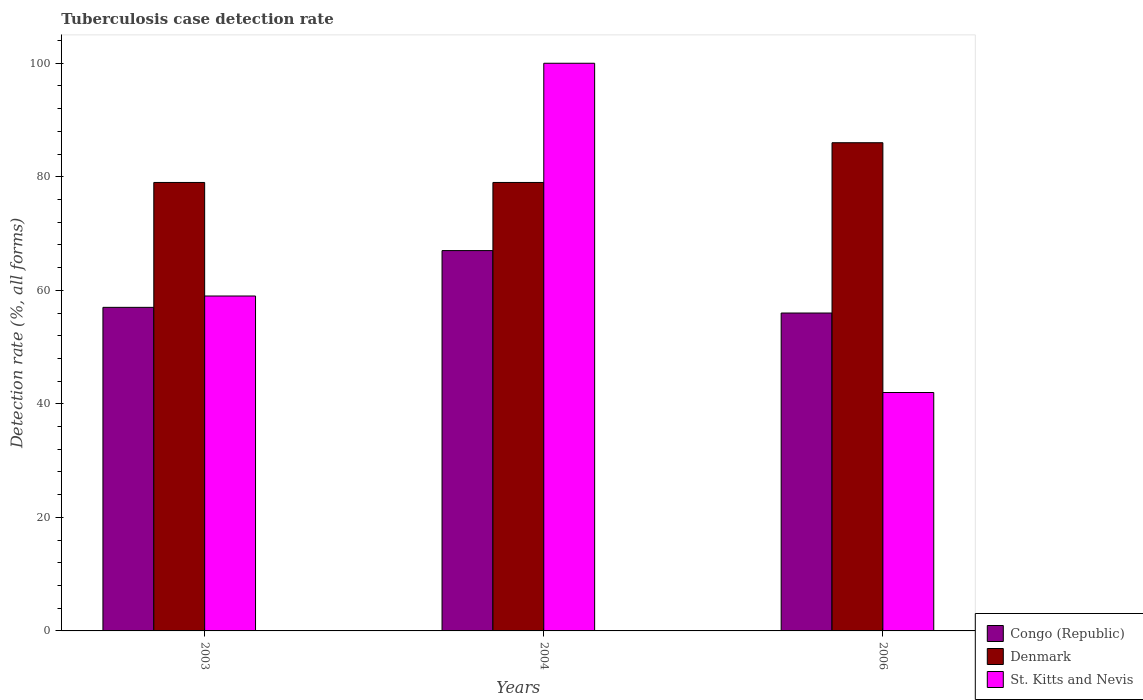Are the number of bars per tick equal to the number of legend labels?
Offer a very short reply. Yes. How many bars are there on the 1st tick from the left?
Your response must be concise. 3. What is the label of the 3rd group of bars from the left?
Offer a very short reply. 2006. In how many cases, is the number of bars for a given year not equal to the number of legend labels?
Your answer should be very brief. 0. What is the tuberculosis case detection rate in in Congo (Republic) in 2006?
Your answer should be compact. 56. Across all years, what is the maximum tuberculosis case detection rate in in Congo (Republic)?
Give a very brief answer. 67. Across all years, what is the minimum tuberculosis case detection rate in in Congo (Republic)?
Provide a short and direct response. 56. In which year was the tuberculosis case detection rate in in Denmark maximum?
Your response must be concise. 2006. What is the total tuberculosis case detection rate in in Denmark in the graph?
Your answer should be very brief. 244. What is the difference between the tuberculosis case detection rate in in St. Kitts and Nevis in 2003 and that in 2004?
Offer a terse response. -41. What is the difference between the tuberculosis case detection rate in in St. Kitts and Nevis in 2003 and the tuberculosis case detection rate in in Congo (Republic) in 2006?
Offer a very short reply. 3. What is the average tuberculosis case detection rate in in St. Kitts and Nevis per year?
Provide a short and direct response. 67. In the year 2003, what is the difference between the tuberculosis case detection rate in in Denmark and tuberculosis case detection rate in in Congo (Republic)?
Your response must be concise. 22. What is the ratio of the tuberculosis case detection rate in in St. Kitts and Nevis in 2004 to that in 2006?
Make the answer very short. 2.38. What is the difference between the highest and the lowest tuberculosis case detection rate in in St. Kitts and Nevis?
Give a very brief answer. 58. What does the 2nd bar from the left in 2006 represents?
Give a very brief answer. Denmark. What does the 1st bar from the right in 2004 represents?
Make the answer very short. St. Kitts and Nevis. Is it the case that in every year, the sum of the tuberculosis case detection rate in in Denmark and tuberculosis case detection rate in in Congo (Republic) is greater than the tuberculosis case detection rate in in St. Kitts and Nevis?
Keep it short and to the point. Yes. How many years are there in the graph?
Provide a short and direct response. 3. Does the graph contain any zero values?
Make the answer very short. No. Where does the legend appear in the graph?
Your answer should be very brief. Bottom right. How are the legend labels stacked?
Give a very brief answer. Vertical. What is the title of the graph?
Ensure brevity in your answer.  Tuberculosis case detection rate. What is the label or title of the Y-axis?
Ensure brevity in your answer.  Detection rate (%, all forms). What is the Detection rate (%, all forms) of Congo (Republic) in 2003?
Offer a terse response. 57. What is the Detection rate (%, all forms) in Denmark in 2003?
Make the answer very short. 79. What is the Detection rate (%, all forms) in St. Kitts and Nevis in 2003?
Make the answer very short. 59. What is the Detection rate (%, all forms) in Congo (Republic) in 2004?
Provide a succinct answer. 67. What is the Detection rate (%, all forms) in Denmark in 2004?
Ensure brevity in your answer.  79. What is the Detection rate (%, all forms) of St. Kitts and Nevis in 2004?
Provide a succinct answer. 100. What is the Detection rate (%, all forms) of Congo (Republic) in 2006?
Provide a succinct answer. 56. What is the Detection rate (%, all forms) in Denmark in 2006?
Your response must be concise. 86. Across all years, what is the maximum Detection rate (%, all forms) of Congo (Republic)?
Give a very brief answer. 67. Across all years, what is the maximum Detection rate (%, all forms) of St. Kitts and Nevis?
Offer a very short reply. 100. Across all years, what is the minimum Detection rate (%, all forms) in Congo (Republic)?
Ensure brevity in your answer.  56. Across all years, what is the minimum Detection rate (%, all forms) in Denmark?
Your answer should be compact. 79. Across all years, what is the minimum Detection rate (%, all forms) of St. Kitts and Nevis?
Your answer should be compact. 42. What is the total Detection rate (%, all forms) of Congo (Republic) in the graph?
Your response must be concise. 180. What is the total Detection rate (%, all forms) in Denmark in the graph?
Provide a short and direct response. 244. What is the total Detection rate (%, all forms) in St. Kitts and Nevis in the graph?
Your answer should be very brief. 201. What is the difference between the Detection rate (%, all forms) in Congo (Republic) in 2003 and that in 2004?
Provide a succinct answer. -10. What is the difference between the Detection rate (%, all forms) in St. Kitts and Nevis in 2003 and that in 2004?
Keep it short and to the point. -41. What is the difference between the Detection rate (%, all forms) of Congo (Republic) in 2003 and that in 2006?
Your answer should be compact. 1. What is the difference between the Detection rate (%, all forms) in Denmark in 2003 and that in 2006?
Provide a succinct answer. -7. What is the difference between the Detection rate (%, all forms) in St. Kitts and Nevis in 2003 and that in 2006?
Your answer should be compact. 17. What is the difference between the Detection rate (%, all forms) of Denmark in 2004 and that in 2006?
Offer a very short reply. -7. What is the difference between the Detection rate (%, all forms) in Congo (Republic) in 2003 and the Detection rate (%, all forms) in St. Kitts and Nevis in 2004?
Give a very brief answer. -43. What is the difference between the Detection rate (%, all forms) in Denmark in 2003 and the Detection rate (%, all forms) in St. Kitts and Nevis in 2006?
Offer a very short reply. 37. What is the difference between the Detection rate (%, all forms) of Congo (Republic) in 2004 and the Detection rate (%, all forms) of Denmark in 2006?
Provide a short and direct response. -19. What is the average Detection rate (%, all forms) in Congo (Republic) per year?
Provide a succinct answer. 60. What is the average Detection rate (%, all forms) in Denmark per year?
Keep it short and to the point. 81.33. In the year 2003, what is the difference between the Detection rate (%, all forms) of Congo (Republic) and Detection rate (%, all forms) of St. Kitts and Nevis?
Offer a very short reply. -2. In the year 2003, what is the difference between the Detection rate (%, all forms) in Denmark and Detection rate (%, all forms) in St. Kitts and Nevis?
Give a very brief answer. 20. In the year 2004, what is the difference between the Detection rate (%, all forms) of Congo (Republic) and Detection rate (%, all forms) of St. Kitts and Nevis?
Your answer should be compact. -33. In the year 2006, what is the difference between the Detection rate (%, all forms) of Congo (Republic) and Detection rate (%, all forms) of Denmark?
Offer a terse response. -30. In the year 2006, what is the difference between the Detection rate (%, all forms) in Congo (Republic) and Detection rate (%, all forms) in St. Kitts and Nevis?
Your response must be concise. 14. What is the ratio of the Detection rate (%, all forms) of Congo (Republic) in 2003 to that in 2004?
Keep it short and to the point. 0.85. What is the ratio of the Detection rate (%, all forms) of Denmark in 2003 to that in 2004?
Make the answer very short. 1. What is the ratio of the Detection rate (%, all forms) of St. Kitts and Nevis in 2003 to that in 2004?
Give a very brief answer. 0.59. What is the ratio of the Detection rate (%, all forms) of Congo (Republic) in 2003 to that in 2006?
Your answer should be very brief. 1.02. What is the ratio of the Detection rate (%, all forms) of Denmark in 2003 to that in 2006?
Your response must be concise. 0.92. What is the ratio of the Detection rate (%, all forms) of St. Kitts and Nevis in 2003 to that in 2006?
Keep it short and to the point. 1.4. What is the ratio of the Detection rate (%, all forms) of Congo (Republic) in 2004 to that in 2006?
Keep it short and to the point. 1.2. What is the ratio of the Detection rate (%, all forms) in Denmark in 2004 to that in 2006?
Provide a succinct answer. 0.92. What is the ratio of the Detection rate (%, all forms) in St. Kitts and Nevis in 2004 to that in 2006?
Make the answer very short. 2.38. What is the difference between the highest and the second highest Detection rate (%, all forms) in St. Kitts and Nevis?
Provide a short and direct response. 41. What is the difference between the highest and the lowest Detection rate (%, all forms) of Congo (Republic)?
Your answer should be very brief. 11. 